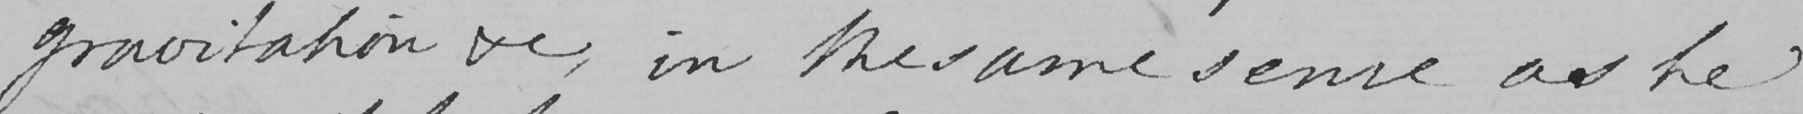Can you tell me what this handwritten text says? gravitation & , in the same sense as he 